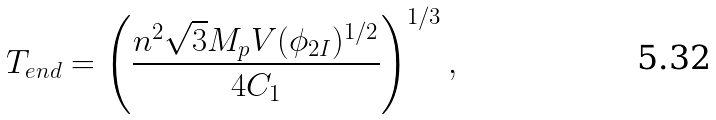<formula> <loc_0><loc_0><loc_500><loc_500>T _ { e n d } = \left ( \frac { n ^ { 2 } \sqrt { 3 } M _ { p } V ( \phi _ { 2 I } ) ^ { 1 / 2 } } { 4 C _ { 1 } } \right ) ^ { 1 / 3 } ,</formula> 